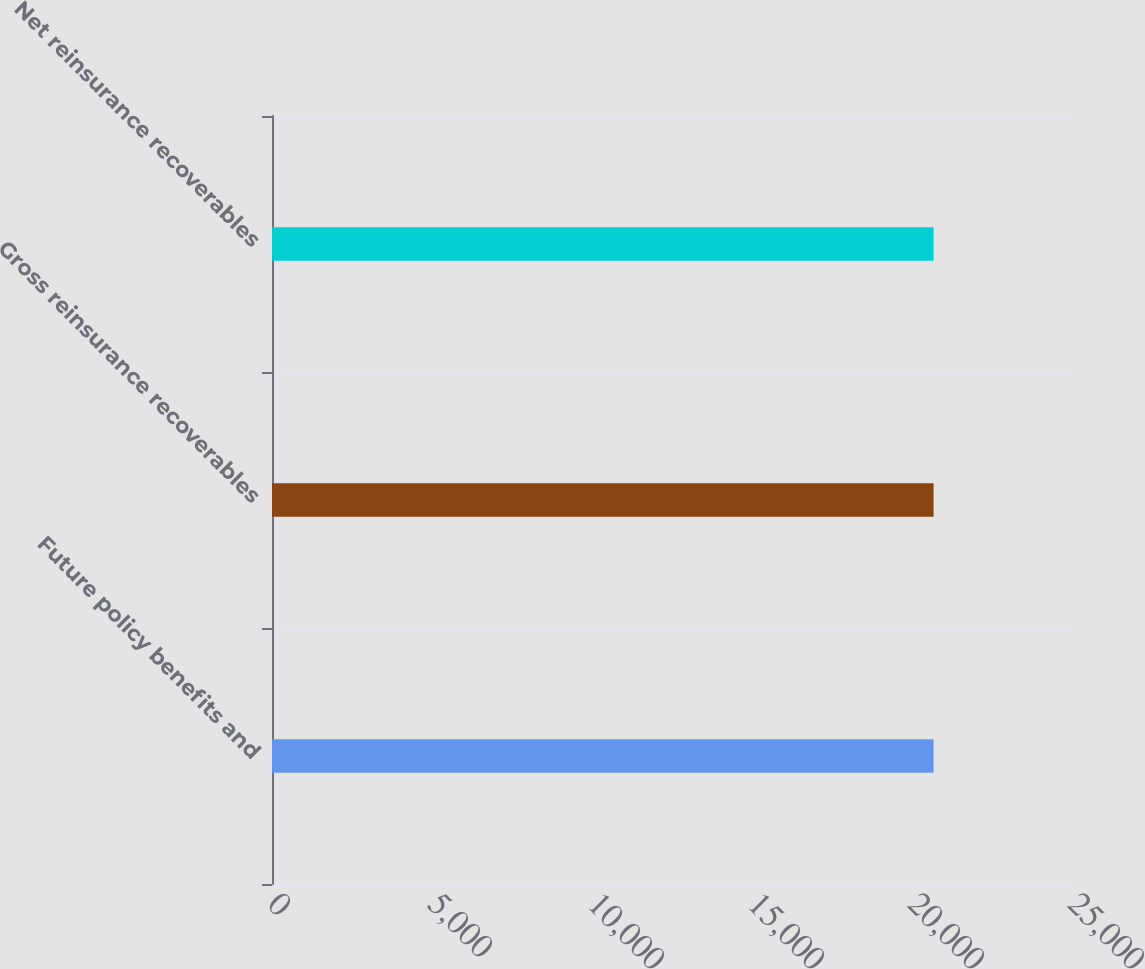Convert chart. <chart><loc_0><loc_0><loc_500><loc_500><bar_chart><fcel>Future policy benefits and<fcel>Gross reinsurance recoverables<fcel>Net reinsurance recoverables<nl><fcel>20674<fcel>20674.1<fcel>20674.2<nl></chart> 